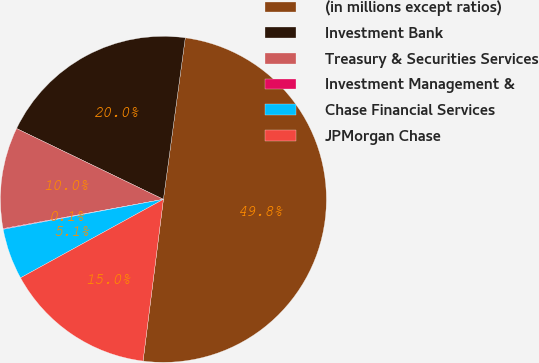Convert chart. <chart><loc_0><loc_0><loc_500><loc_500><pie_chart><fcel>(in millions except ratios)<fcel>Investment Bank<fcel>Treasury & Securities Services<fcel>Investment Management &<fcel>Chase Financial Services<fcel>JPMorgan Chase<nl><fcel>49.85%<fcel>19.99%<fcel>10.03%<fcel>0.07%<fcel>5.05%<fcel>15.01%<nl></chart> 